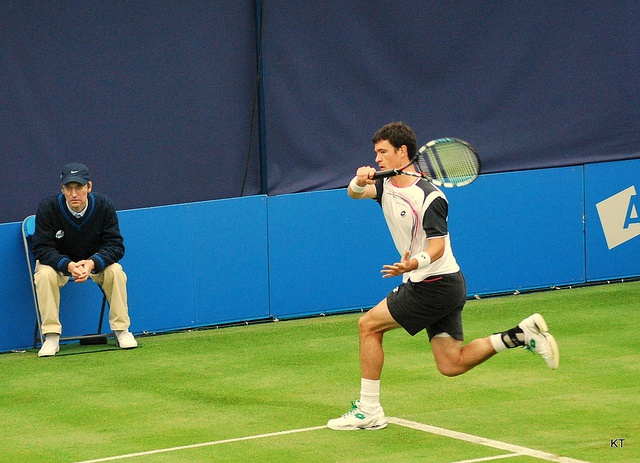Describe the objects in this image and their specific colors. I can see people in navy, black, tan, and lightyellow tones, people in navy, black, and tan tones, tennis racket in navy, tan, gray, darkgray, and black tones, and chair in navy, black, blue, and gray tones in this image. 